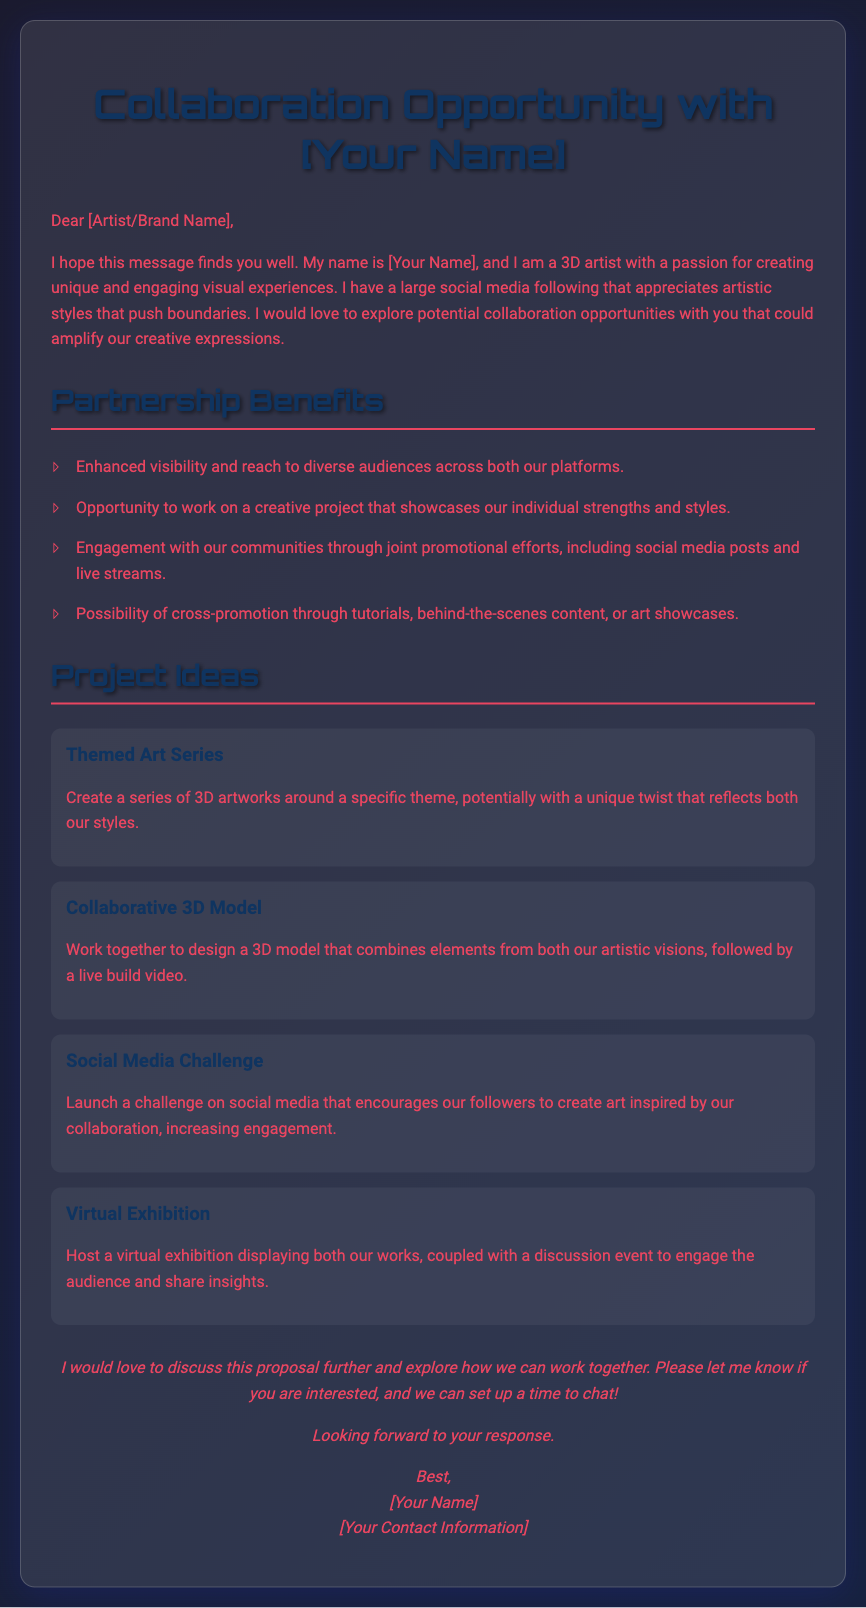What is the title of the document? The title of the document is clearly stated in the heading of the HTML, indicating the purpose of the content.
Answer: Collaboration Opportunity with [Your Name] Who is the intended recipient of the proposal? The document addresses "Dear [Artist/Brand Name]," indicating it is intended for other artists or brands.
Answer: [Artist/Brand Name] What are two benefits mentioned for partnership? The benefits are listed in a bullet point format and describe the advantages of collaboration.
Answer: Enhanced visibility and Engagement with our communities Name one project idea presented in the document. Project ideas are offered in a separate section to stimulate interest and proposals for collaboration.
Answer: Themed Art Series What is the main call to action in the proposal? The conclusion contains a request for further discussion and sets the tone for subsequent communication.
Answer: Please let me know if you are interested What font is used for headings in the document? The style section describes the font choices used for different text elements, particularly for headings.
Answer: Orbitron 